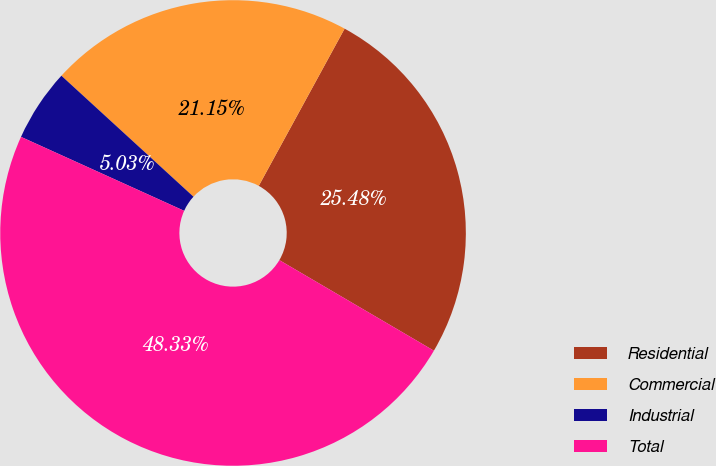Convert chart to OTSL. <chart><loc_0><loc_0><loc_500><loc_500><pie_chart><fcel>Residential<fcel>Commercial<fcel>Industrial<fcel>Total<nl><fcel>25.48%<fcel>21.15%<fcel>5.03%<fcel>48.33%<nl></chart> 